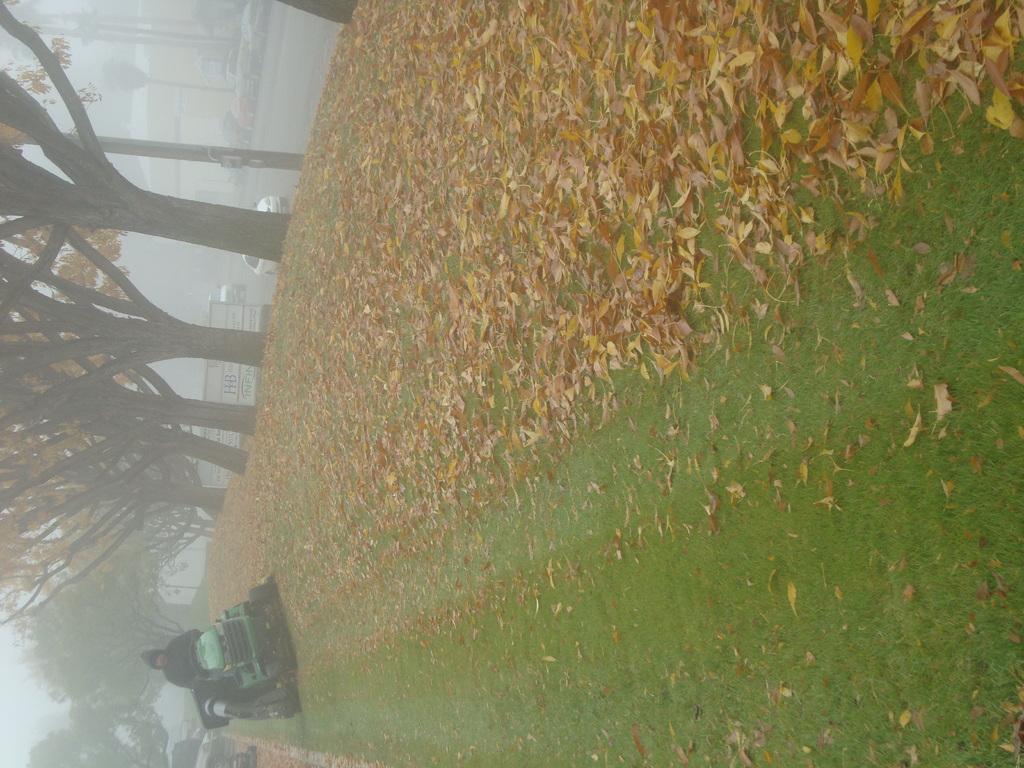How would you summarize this image in a sentence or two? This image is in the left direction. At the bottom there is a vehicle and a person. On the right side, I can see the grass and dry leaves on the ground. On the left side there are trees and also I can see few vehicles on the roads. 